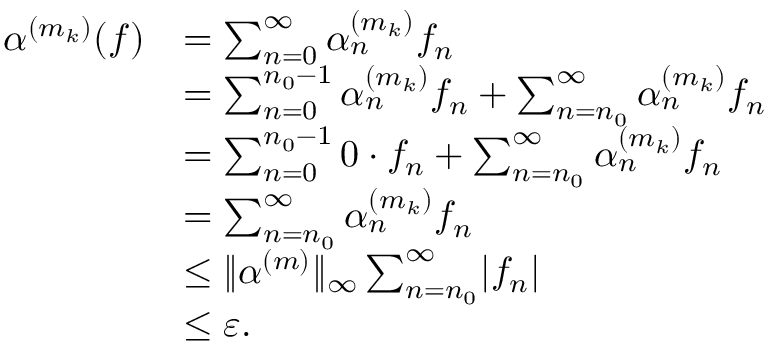Convert formula to latex. <formula><loc_0><loc_0><loc_500><loc_500>\begin{array} { r l } { \alpha ^ { ( m _ { k } ) } ( f ) } & { = \sum _ { n = 0 } ^ { \infty } \alpha _ { n } ^ { ( m _ { k } ) } f _ { n } } \\ & { = \sum _ { n = 0 } ^ { n _ { 0 } - 1 } \alpha _ { n } ^ { ( m _ { k } ) } f _ { n } + \sum _ { n = n _ { 0 } } ^ { \infty } \alpha _ { n } ^ { ( m _ { k } ) } f _ { n } } \\ & { = \sum _ { n = 0 } ^ { n _ { 0 } - 1 } 0 \cdot f _ { n } + \sum _ { n = n _ { 0 } } ^ { \infty } \alpha _ { n } ^ { ( m _ { k } ) } f _ { n } } \\ & { = \sum _ { n = n _ { 0 } } ^ { \infty } \alpha _ { n } ^ { ( m _ { k } ) } f _ { n } } \\ & { \leq \| \alpha ^ { ( m ) } \| _ { \infty } \sum _ { n = n _ { 0 } } ^ { \infty } | f _ { n } | } \\ & { \leq { \varepsilon } . } \end{array}</formula> 